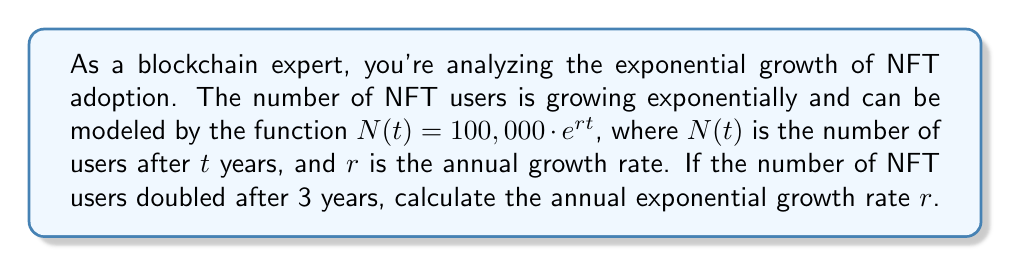Can you solve this math problem? To solve this problem, we'll follow these steps:

1) We know that the number of users doubled after 3 years. This means:

   $N(3) = 2 \cdot N(0)$

2) Let's substitute this into our exponential function:

   $100,000 \cdot e^{3r} = 2 \cdot 100,000$

3) We can simplify this equation:

   $e^{3r} = 2$

4) Now, let's take the natural logarithm of both sides:

   $\ln(e^{3r}) = \ln(2)$

5) The left side simplifies due to the properties of logarithms:

   $3r = \ln(2)$

6) Now we can solve for $r$:

   $r = \frac{\ln(2)}{3}$

7) To get a decimal approximation, we can evaluate this:

   $r \approx 0.2310$

This means the annual growth rate is approximately 23.10%.
Answer: $r = \frac{\ln(2)}{3} \approx 0.2310$ or about 23.10% per year 